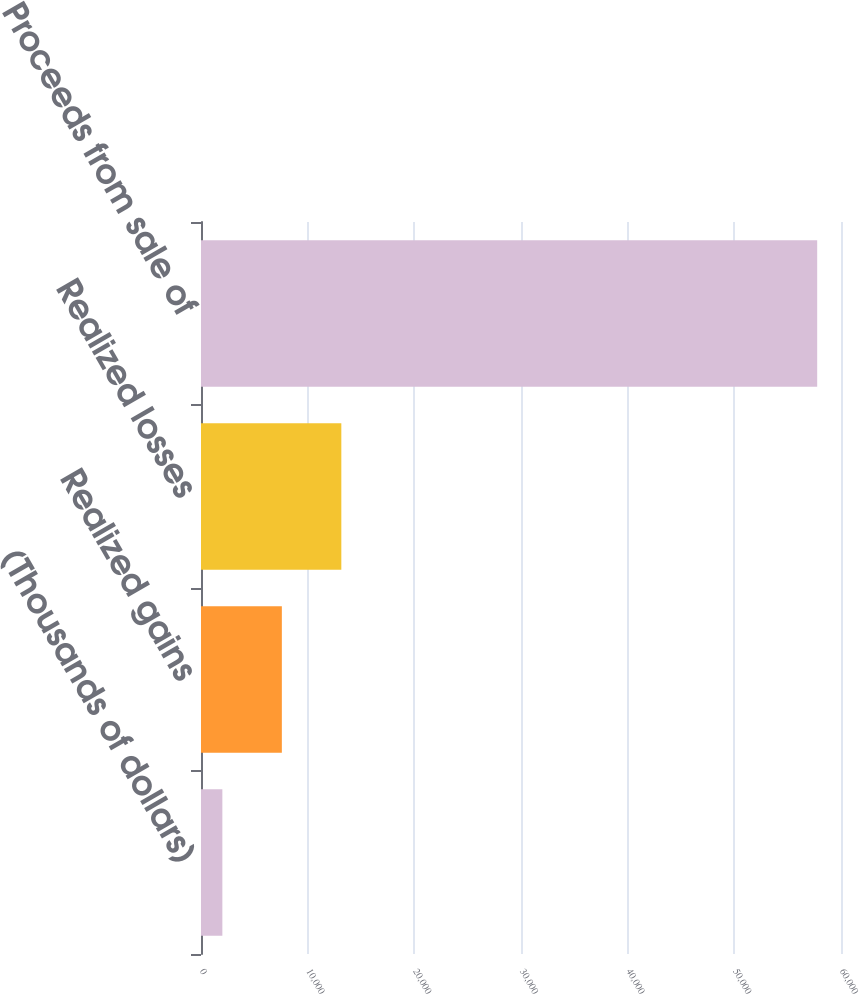Convert chart. <chart><loc_0><loc_0><loc_500><loc_500><bar_chart><fcel>(Thousands of dollars)<fcel>Realized gains<fcel>Realized losses<fcel>Proceeds from sale of<nl><fcel>2003<fcel>7579.5<fcel>13156<fcel>57768<nl></chart> 